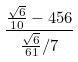Convert formula to latex. <formula><loc_0><loc_0><loc_500><loc_500>\frac { \frac { \sqrt { 6 } } { 1 0 } - 4 5 6 } { \frac { \sqrt { 6 } } { 6 1 } / 7 }</formula> 